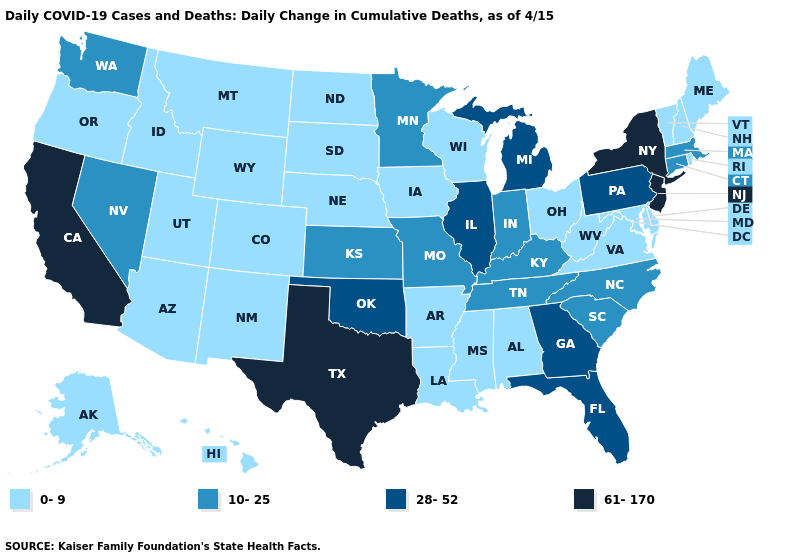Among the states that border Ohio , which have the lowest value?
Write a very short answer. West Virginia. Which states hav the highest value in the MidWest?
Answer briefly. Illinois, Michigan. What is the value of Rhode Island?
Short answer required. 0-9. Name the states that have a value in the range 10-25?
Concise answer only. Connecticut, Indiana, Kansas, Kentucky, Massachusetts, Minnesota, Missouri, Nevada, North Carolina, South Carolina, Tennessee, Washington. Name the states that have a value in the range 10-25?
Answer briefly. Connecticut, Indiana, Kansas, Kentucky, Massachusetts, Minnesota, Missouri, Nevada, North Carolina, South Carolina, Tennessee, Washington. What is the lowest value in the Northeast?
Quick response, please. 0-9. What is the value of Colorado?
Be succinct. 0-9. Does California have the same value as New Jersey?
Short answer required. Yes. Does New Jersey have the highest value in the USA?
Quick response, please. Yes. What is the value of Kentucky?
Be succinct. 10-25. Which states have the lowest value in the USA?
Be succinct. Alabama, Alaska, Arizona, Arkansas, Colorado, Delaware, Hawaii, Idaho, Iowa, Louisiana, Maine, Maryland, Mississippi, Montana, Nebraska, New Hampshire, New Mexico, North Dakota, Ohio, Oregon, Rhode Island, South Dakota, Utah, Vermont, Virginia, West Virginia, Wisconsin, Wyoming. Name the states that have a value in the range 61-170?
Keep it brief. California, New Jersey, New York, Texas. Does Iowa have a lower value than Wisconsin?
Write a very short answer. No. Which states hav the highest value in the West?
Write a very short answer. California. Among the states that border Illinois , does Iowa have the highest value?
Write a very short answer. No. 